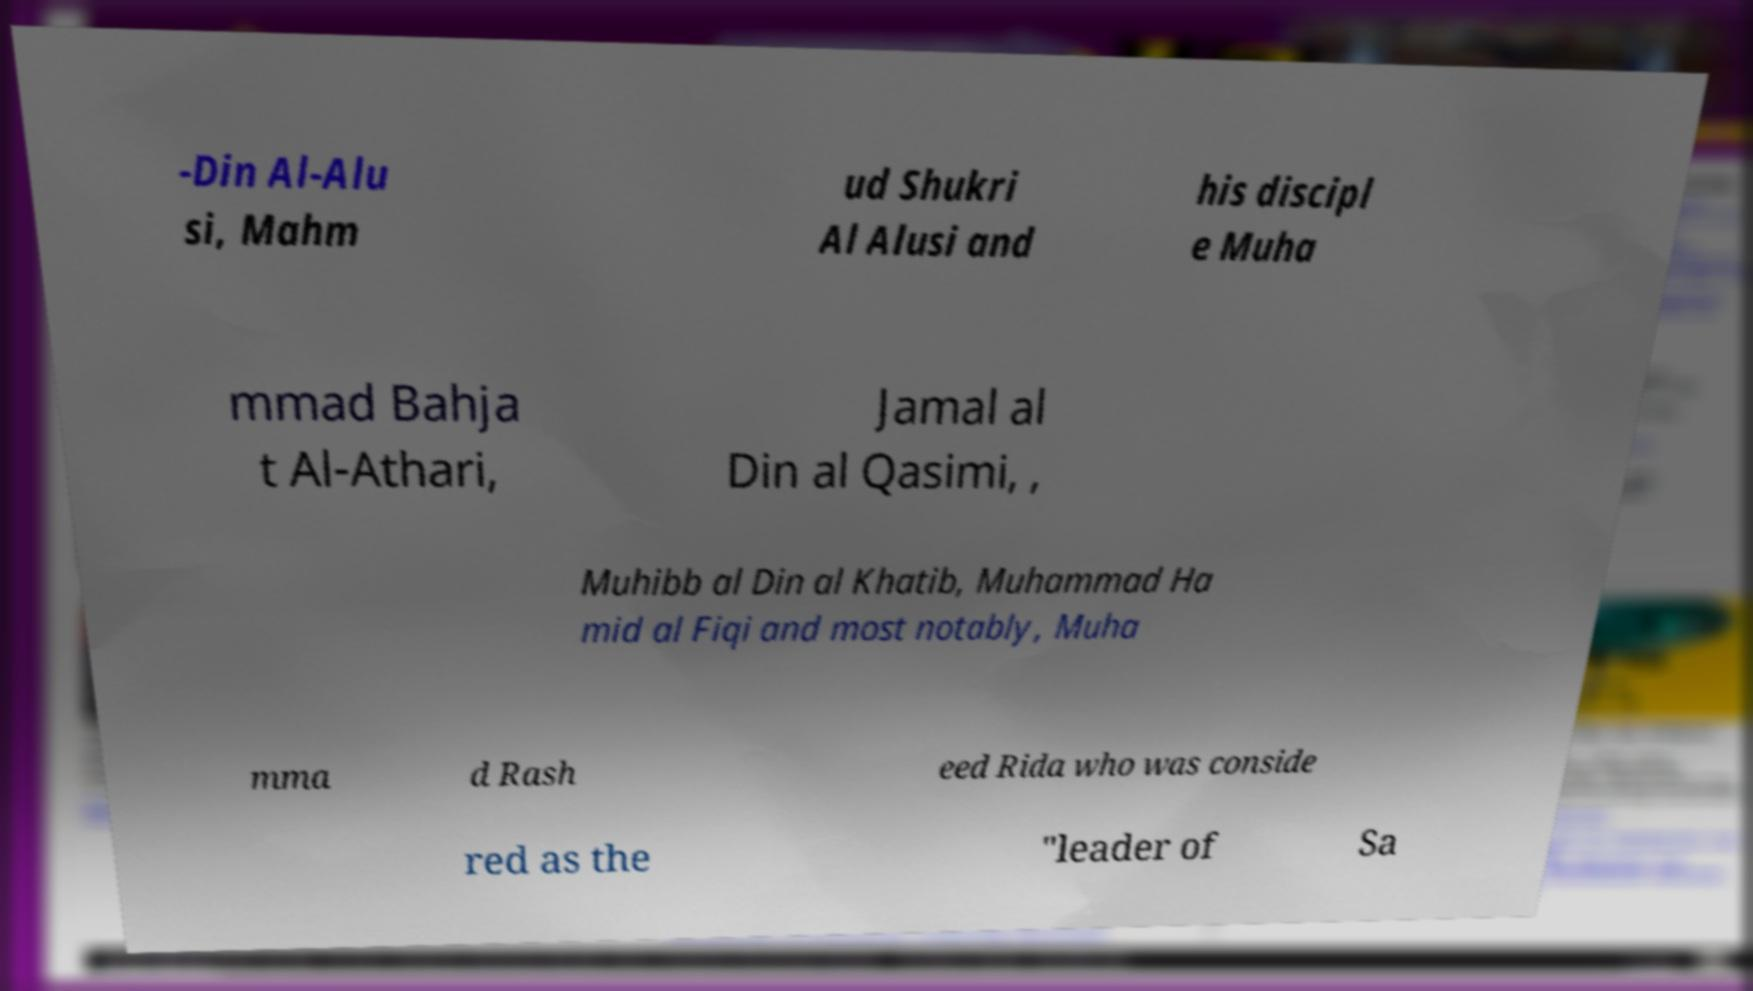Could you assist in decoding the text presented in this image and type it out clearly? -Din Al-Alu si, Mahm ud Shukri Al Alusi and his discipl e Muha mmad Bahja t Al-Athari, Jamal al Din al Qasimi, , Muhibb al Din al Khatib, Muhammad Ha mid al Fiqi and most notably, Muha mma d Rash eed Rida who was conside red as the "leader of Sa 